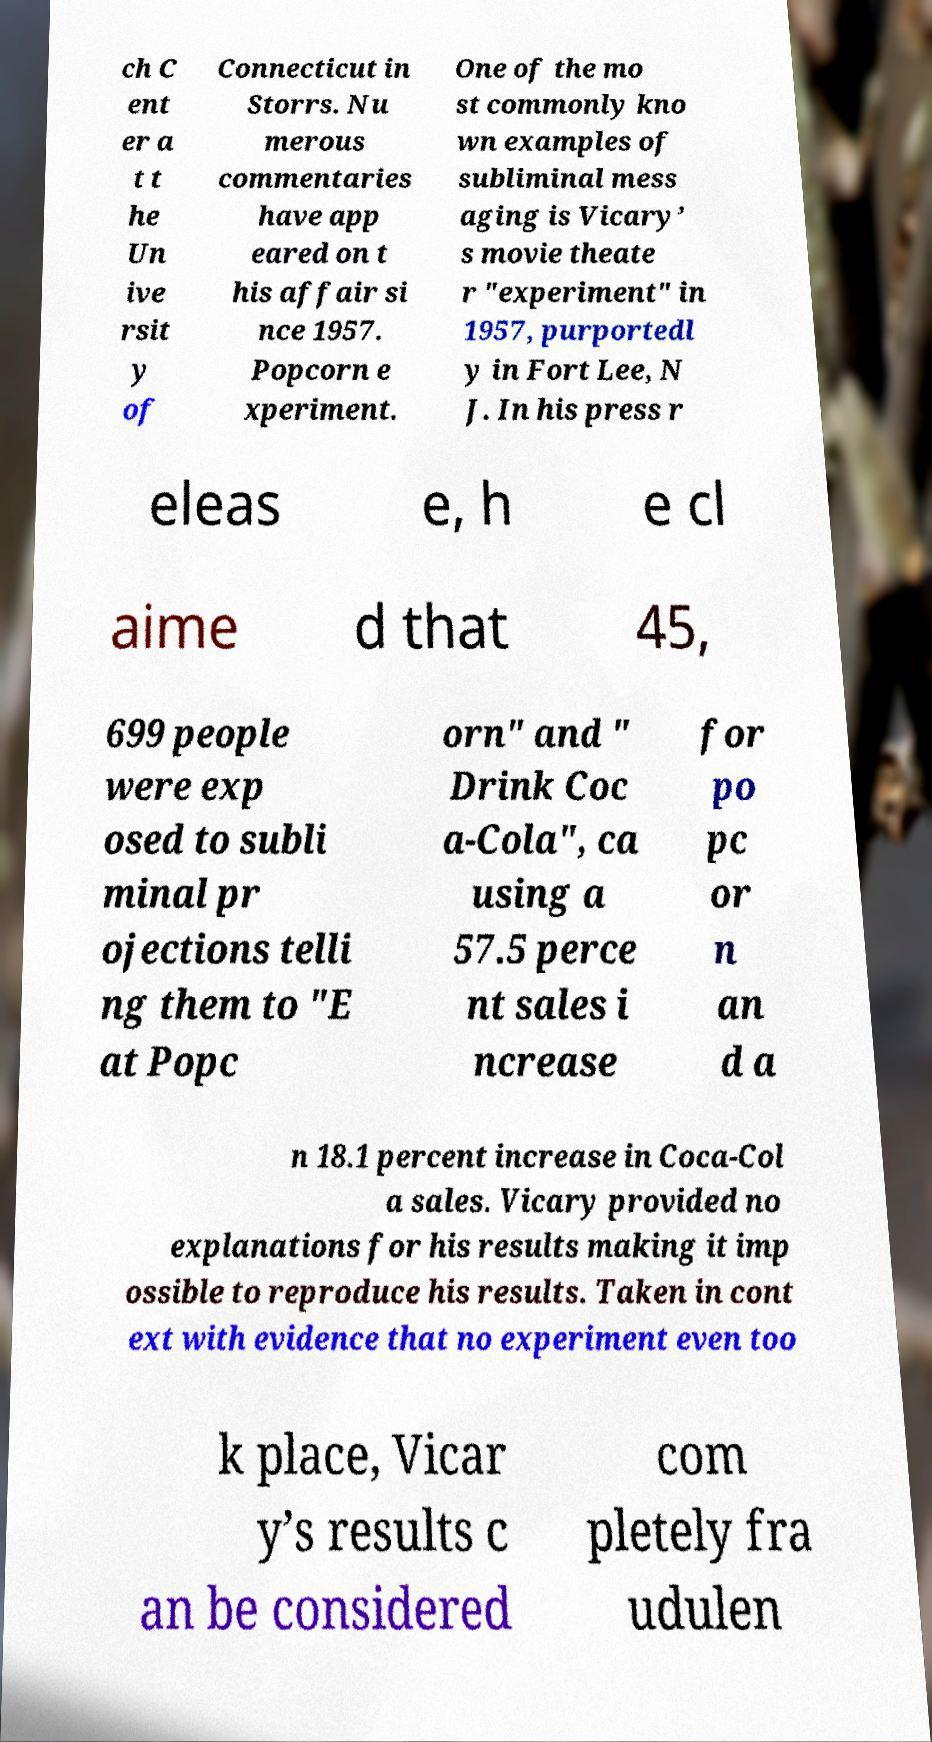Could you assist in decoding the text presented in this image and type it out clearly? ch C ent er a t t he Un ive rsit y of Connecticut in Storrs. Nu merous commentaries have app eared on t his affair si nce 1957. Popcorn e xperiment. One of the mo st commonly kno wn examples of subliminal mess aging is Vicary’ s movie theate r "experiment" in 1957, purportedl y in Fort Lee, N J. In his press r eleas e, h e cl aime d that 45, 699 people were exp osed to subli minal pr ojections telli ng them to "E at Popc orn" and " Drink Coc a-Cola", ca using a 57.5 perce nt sales i ncrease for po pc or n an d a n 18.1 percent increase in Coca-Col a sales. Vicary provided no explanations for his results making it imp ossible to reproduce his results. Taken in cont ext with evidence that no experiment even too k place, Vicar y’s results c an be considered com pletely fra udulen 